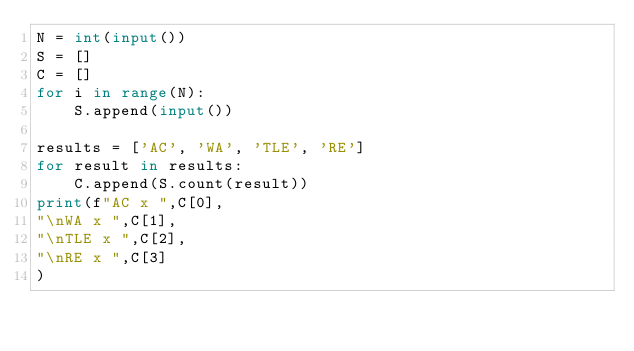<code> <loc_0><loc_0><loc_500><loc_500><_Python_>N = int(input())
S = []
C = []
for i in range(N):
    S.append(input())

results = ['AC', 'WA', 'TLE', 'RE']
for result in results:
    C.append(S.count(result))
print(f"AC x ",C[0],
"\nWA x ",C[1],
"\nTLE x ",C[2],
"\nRE x ",C[3]
)   </code> 